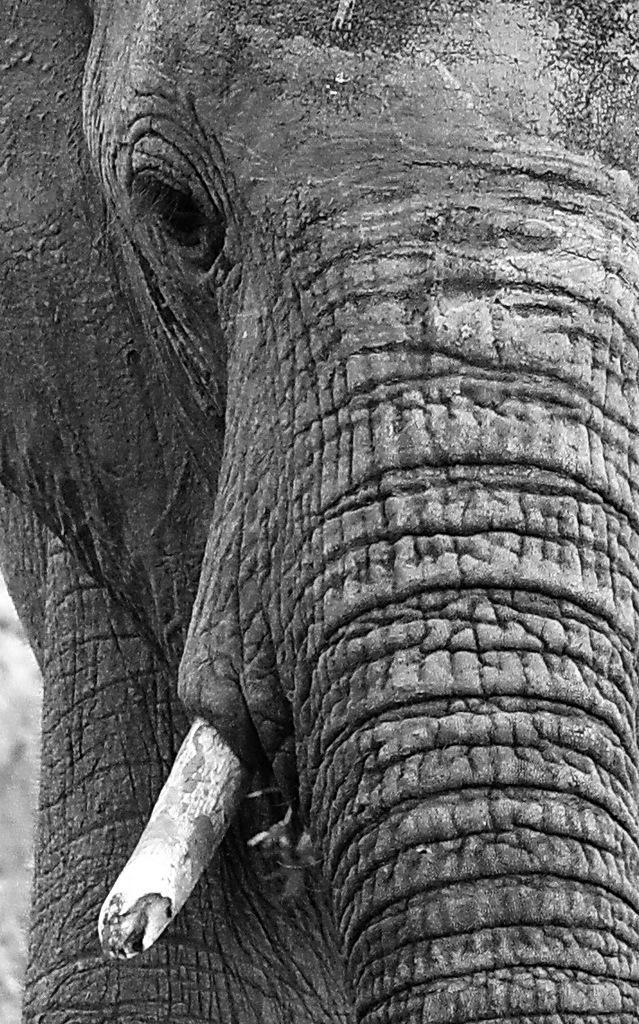In one or two sentences, can you explain what this image depicts? In this picture we can see an elephant and in the background it is blurry. 